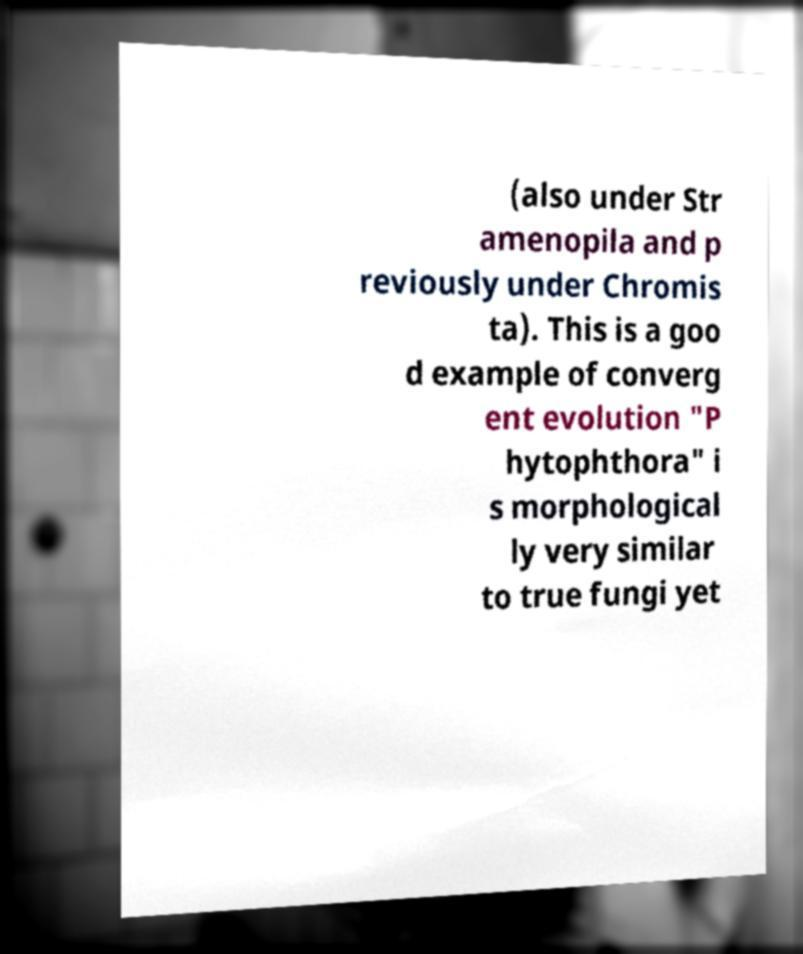Could you extract and type out the text from this image? (also under Str amenopila and p reviously under Chromis ta). This is a goo d example of converg ent evolution "P hytophthora" i s morphological ly very similar to true fungi yet 